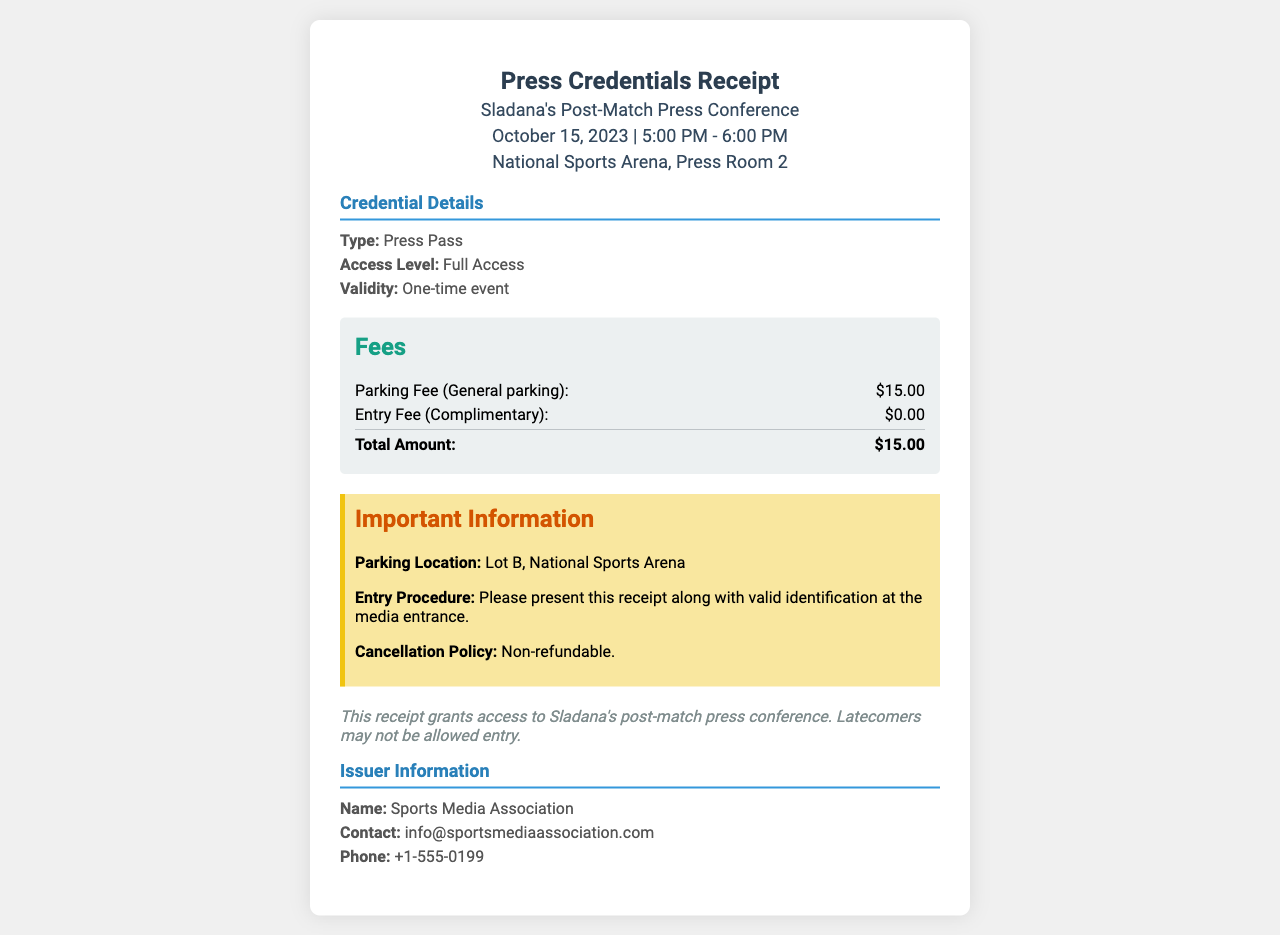What date is Sladana's press conference scheduled? The date of Sladana's press conference is mentioned in the document as October 15, 2023.
Answer: October 15, 2023 What is the parking fee? The parking fee listed in the document is presented under the Fees section as $15.00.
Answer: $15.00 What is the entry fee for the event? The entry fee is specified as complimentary, which means it is listed as $0.00.
Answer: $0.00 What is the access level of the press pass? The document states the access level as Full Access, found in the Credential Details section.
Answer: Full Access Where is the parking location? The parking location is noted in the Important Information section as Lot B, National Sports Arena.
Answer: Lot B, National Sports Arena What should be presented at the media entrance? The document instructs to present this receipt along with valid identification at the media entrance.
Answer: This receipt and valid identification What is the total amount of fees listed? The total fees amount at the end of the Fees section is given as $15.00.
Answer: $15.00 Is the entry fee refundable? The Cancellation Policy states that the fee is non-refundable, which implies it is not refundable.
Answer: Non-refundable Who issued the receipt? The Issuer Information section names the organization that issued the receipt as Sports Media Association.
Answer: Sports Media Association 